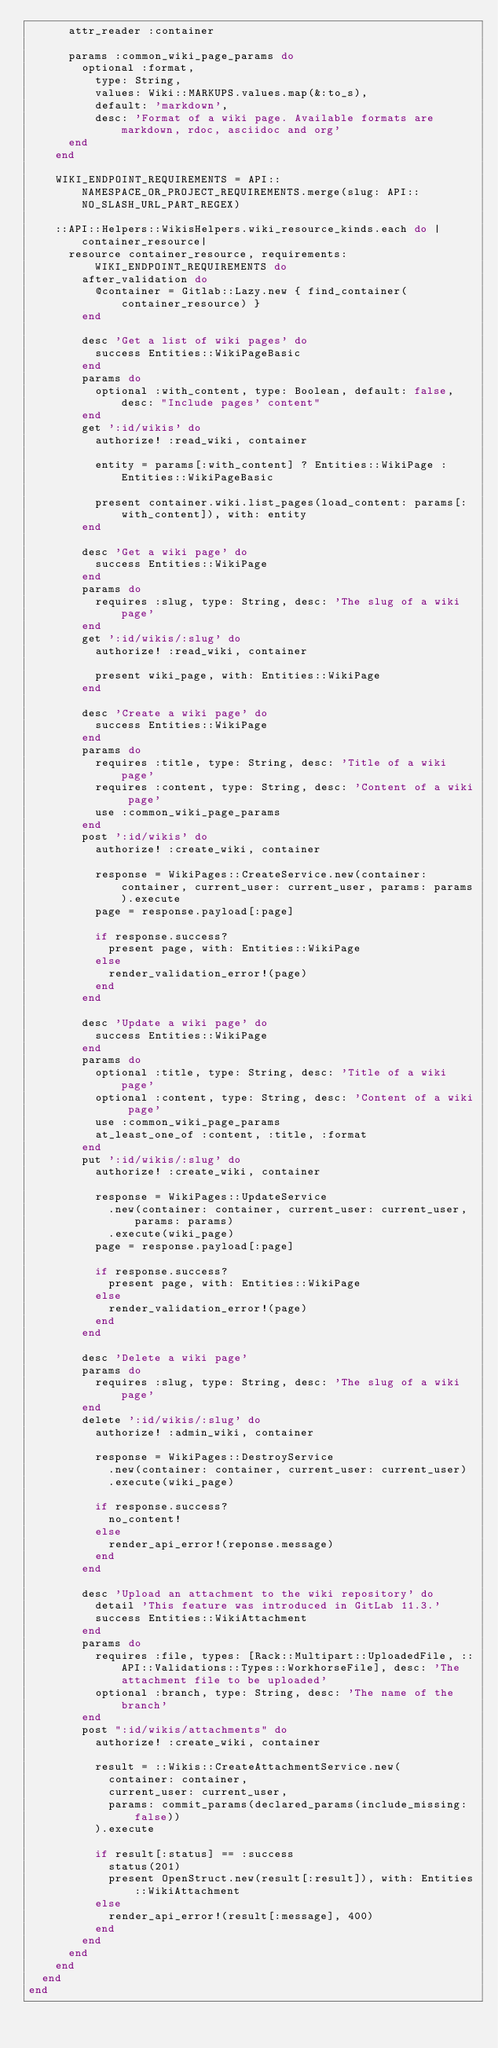<code> <loc_0><loc_0><loc_500><loc_500><_Ruby_>      attr_reader :container

      params :common_wiki_page_params do
        optional :format,
          type: String,
          values: Wiki::MARKUPS.values.map(&:to_s),
          default: 'markdown',
          desc: 'Format of a wiki page. Available formats are markdown, rdoc, asciidoc and org'
      end
    end

    WIKI_ENDPOINT_REQUIREMENTS = API::NAMESPACE_OR_PROJECT_REQUIREMENTS.merge(slug: API::NO_SLASH_URL_PART_REGEX)

    ::API::Helpers::WikisHelpers.wiki_resource_kinds.each do |container_resource|
      resource container_resource, requirements: WIKI_ENDPOINT_REQUIREMENTS do
        after_validation do
          @container = Gitlab::Lazy.new { find_container(container_resource) }
        end

        desc 'Get a list of wiki pages' do
          success Entities::WikiPageBasic
        end
        params do
          optional :with_content, type: Boolean, default: false, desc: "Include pages' content"
        end
        get ':id/wikis' do
          authorize! :read_wiki, container

          entity = params[:with_content] ? Entities::WikiPage : Entities::WikiPageBasic

          present container.wiki.list_pages(load_content: params[:with_content]), with: entity
        end

        desc 'Get a wiki page' do
          success Entities::WikiPage
        end
        params do
          requires :slug, type: String, desc: 'The slug of a wiki page'
        end
        get ':id/wikis/:slug' do
          authorize! :read_wiki, container

          present wiki_page, with: Entities::WikiPage
        end

        desc 'Create a wiki page' do
          success Entities::WikiPage
        end
        params do
          requires :title, type: String, desc: 'Title of a wiki page'
          requires :content, type: String, desc: 'Content of a wiki page'
          use :common_wiki_page_params
        end
        post ':id/wikis' do
          authorize! :create_wiki, container

          response = WikiPages::CreateService.new(container: container, current_user: current_user, params: params).execute
          page = response.payload[:page]

          if response.success?
            present page, with: Entities::WikiPage
          else
            render_validation_error!(page)
          end
        end

        desc 'Update a wiki page' do
          success Entities::WikiPage
        end
        params do
          optional :title, type: String, desc: 'Title of a wiki page'
          optional :content, type: String, desc: 'Content of a wiki page'
          use :common_wiki_page_params
          at_least_one_of :content, :title, :format
        end
        put ':id/wikis/:slug' do
          authorize! :create_wiki, container

          response = WikiPages::UpdateService
            .new(container: container, current_user: current_user, params: params)
            .execute(wiki_page)
          page = response.payload[:page]

          if response.success?
            present page, with: Entities::WikiPage
          else
            render_validation_error!(page)
          end
        end

        desc 'Delete a wiki page'
        params do
          requires :slug, type: String, desc: 'The slug of a wiki page'
        end
        delete ':id/wikis/:slug' do
          authorize! :admin_wiki, container

          response = WikiPages::DestroyService
            .new(container: container, current_user: current_user)
            .execute(wiki_page)

          if response.success?
            no_content!
          else
            render_api_error!(reponse.message)
          end
        end

        desc 'Upload an attachment to the wiki repository' do
          detail 'This feature was introduced in GitLab 11.3.'
          success Entities::WikiAttachment
        end
        params do
          requires :file, types: [Rack::Multipart::UploadedFile, ::API::Validations::Types::WorkhorseFile], desc: 'The attachment file to be uploaded'
          optional :branch, type: String, desc: 'The name of the branch'
        end
        post ":id/wikis/attachments" do
          authorize! :create_wiki, container

          result = ::Wikis::CreateAttachmentService.new(
            container: container,
            current_user: current_user,
            params: commit_params(declared_params(include_missing: false))
          ).execute

          if result[:status] == :success
            status(201)
            present OpenStruct.new(result[:result]), with: Entities::WikiAttachment
          else
            render_api_error!(result[:message], 400)
          end
        end
      end
    end
  end
end
</code> 